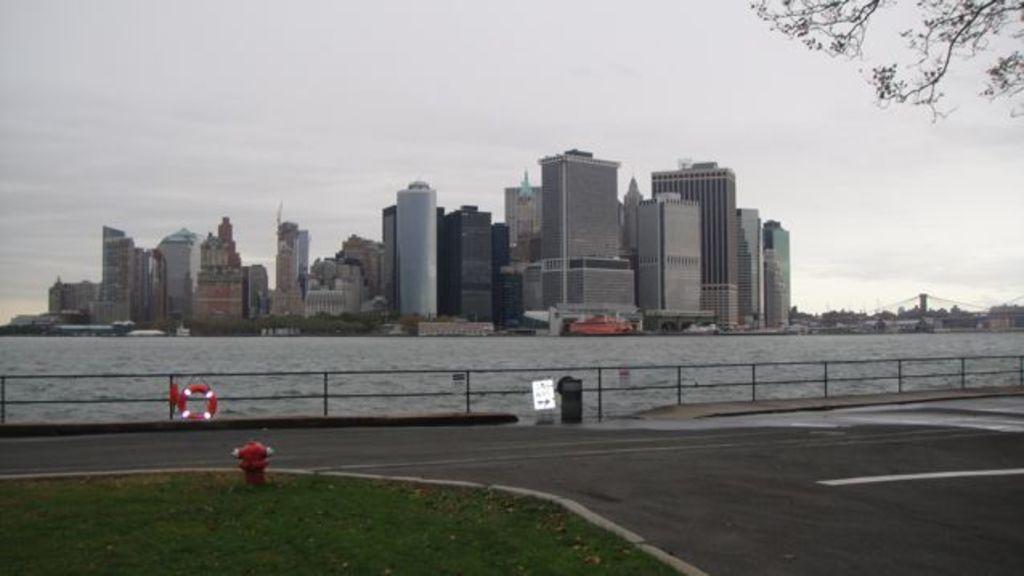Can you describe this image briefly? In this picture we can see a hydrant on the ground, here we can see the road, buildings, trees and some objects and we can see sky in the background. 